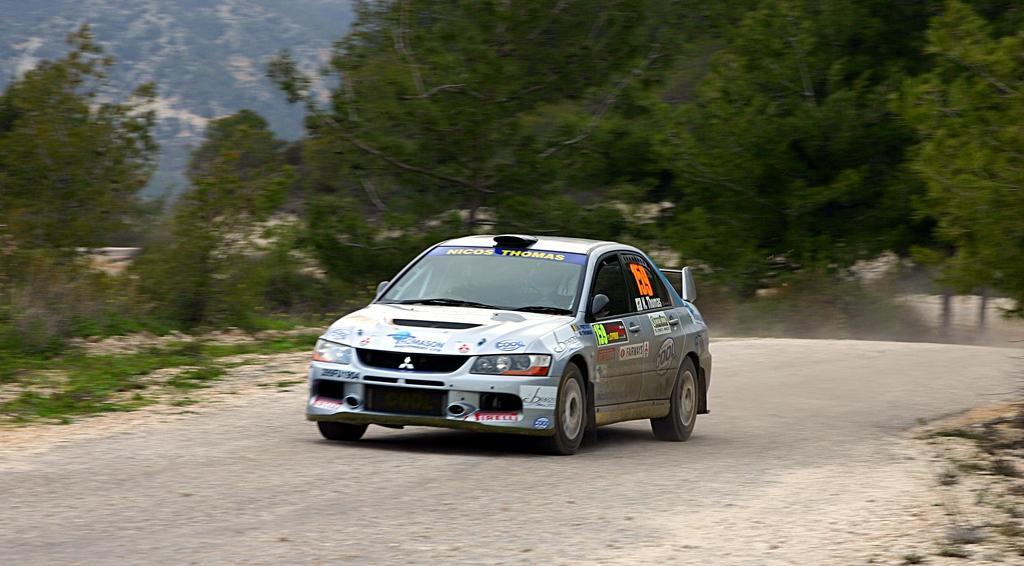Please provide a concise description of this image. In front of the image there is a car on the road. In the background of the image there are trees. At the top of the image there are clouds in the sky. 